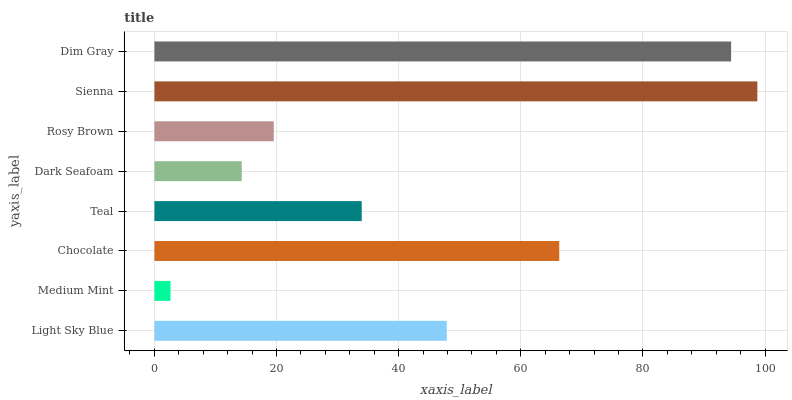Is Medium Mint the minimum?
Answer yes or no. Yes. Is Sienna the maximum?
Answer yes or no. Yes. Is Chocolate the minimum?
Answer yes or no. No. Is Chocolate the maximum?
Answer yes or no. No. Is Chocolate greater than Medium Mint?
Answer yes or no. Yes. Is Medium Mint less than Chocolate?
Answer yes or no. Yes. Is Medium Mint greater than Chocolate?
Answer yes or no. No. Is Chocolate less than Medium Mint?
Answer yes or no. No. Is Light Sky Blue the high median?
Answer yes or no. Yes. Is Teal the low median?
Answer yes or no. Yes. Is Dark Seafoam the high median?
Answer yes or no. No. Is Light Sky Blue the low median?
Answer yes or no. No. 